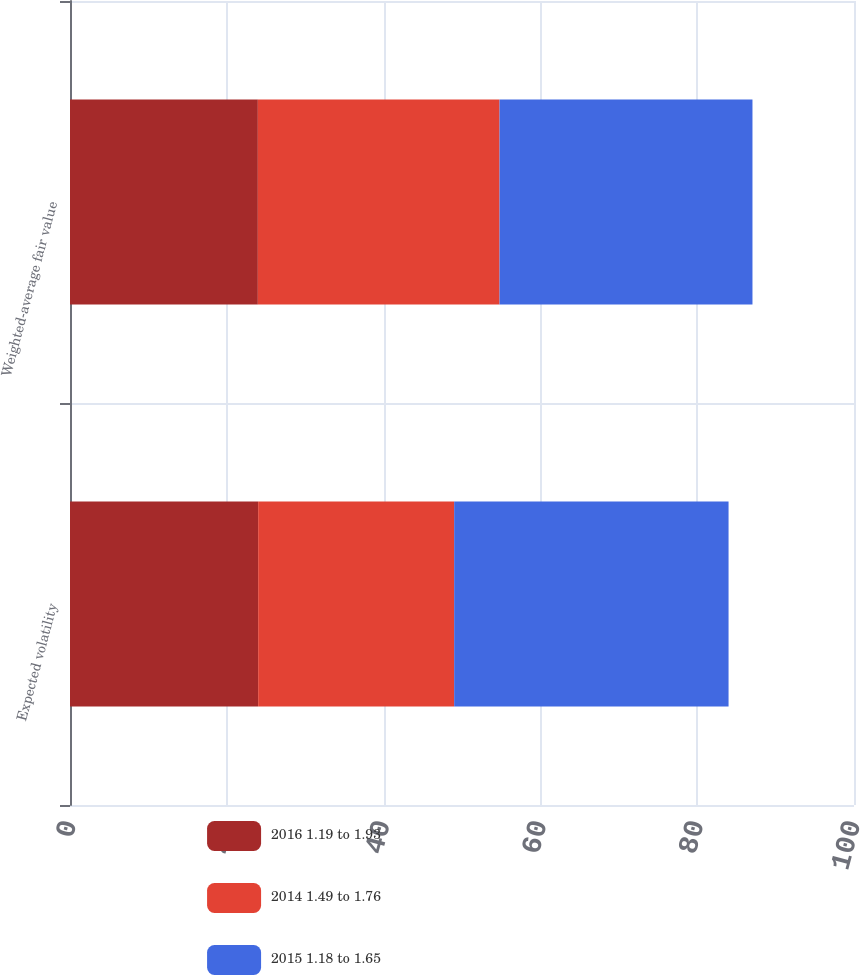<chart> <loc_0><loc_0><loc_500><loc_500><stacked_bar_chart><ecel><fcel>Expected volatility<fcel>Weighted-average fair value<nl><fcel>2016 1.19 to 1.93<fcel>24<fcel>23.96<nl><fcel>2014 1.49 to 1.76<fcel>25<fcel>30.83<nl><fcel>2015 1.18 to 1.65<fcel>35<fcel>32.26<nl></chart> 